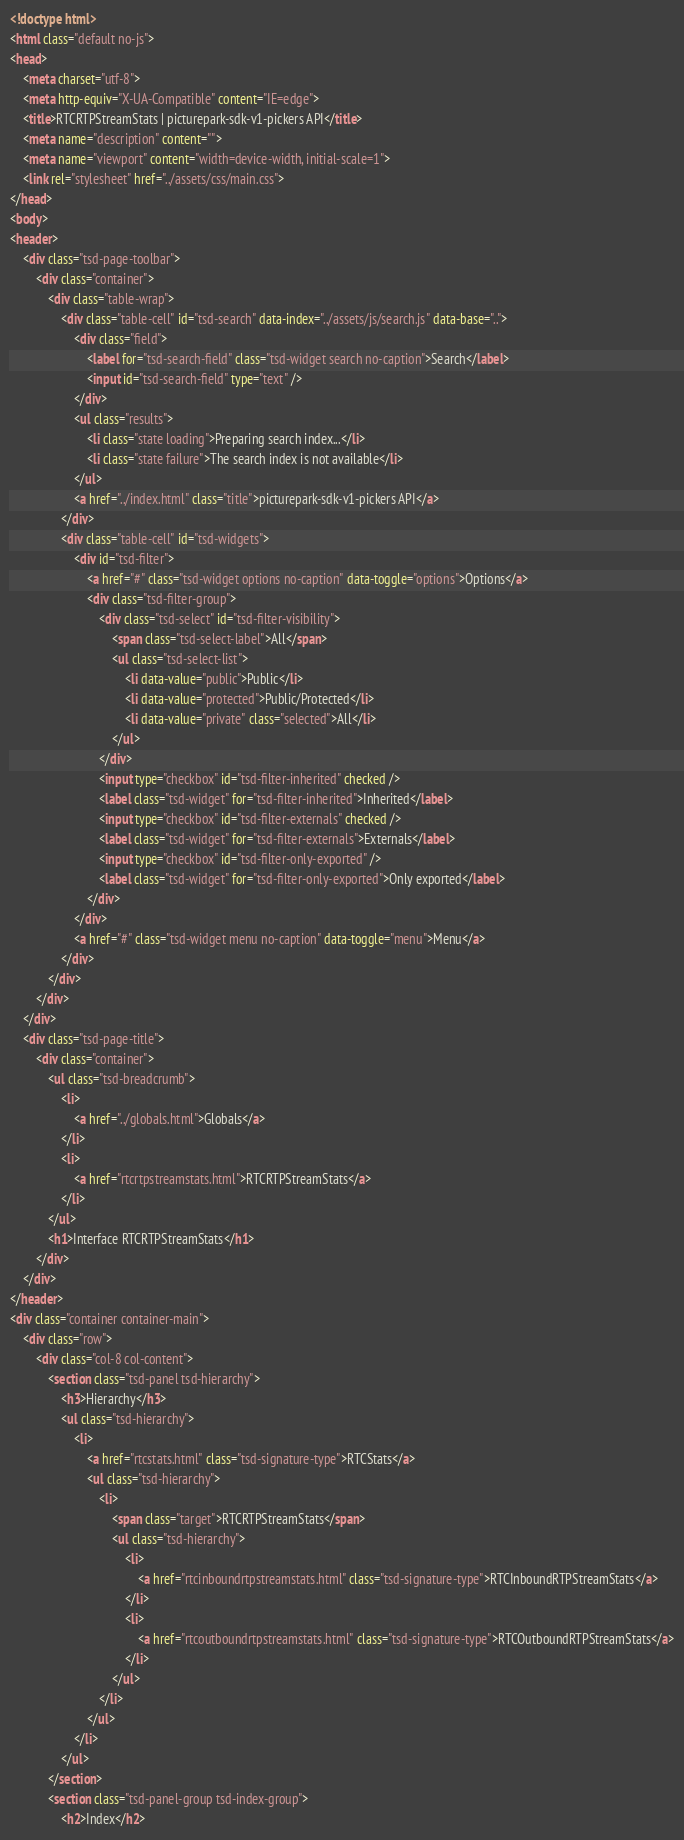<code> <loc_0><loc_0><loc_500><loc_500><_HTML_><!doctype html>
<html class="default no-js">
<head>
	<meta charset="utf-8">
	<meta http-equiv="X-UA-Compatible" content="IE=edge">
	<title>RTCRTPStreamStats | picturepark-sdk-v1-pickers API</title>
	<meta name="description" content="">
	<meta name="viewport" content="width=device-width, initial-scale=1">
	<link rel="stylesheet" href="../assets/css/main.css">
</head>
<body>
<header>
	<div class="tsd-page-toolbar">
		<div class="container">
			<div class="table-wrap">
				<div class="table-cell" id="tsd-search" data-index="../assets/js/search.js" data-base="..">
					<div class="field">
						<label for="tsd-search-field" class="tsd-widget search no-caption">Search</label>
						<input id="tsd-search-field" type="text" />
					</div>
					<ul class="results">
						<li class="state loading">Preparing search index...</li>
						<li class="state failure">The search index is not available</li>
					</ul>
					<a href="../index.html" class="title">picturepark-sdk-v1-pickers API</a>
				</div>
				<div class="table-cell" id="tsd-widgets">
					<div id="tsd-filter">
						<a href="#" class="tsd-widget options no-caption" data-toggle="options">Options</a>
						<div class="tsd-filter-group">
							<div class="tsd-select" id="tsd-filter-visibility">
								<span class="tsd-select-label">All</span>
								<ul class="tsd-select-list">
									<li data-value="public">Public</li>
									<li data-value="protected">Public/Protected</li>
									<li data-value="private" class="selected">All</li>
								</ul>
							</div>
							<input type="checkbox" id="tsd-filter-inherited" checked />
							<label class="tsd-widget" for="tsd-filter-inherited">Inherited</label>
							<input type="checkbox" id="tsd-filter-externals" checked />
							<label class="tsd-widget" for="tsd-filter-externals">Externals</label>
							<input type="checkbox" id="tsd-filter-only-exported" />
							<label class="tsd-widget" for="tsd-filter-only-exported">Only exported</label>
						</div>
					</div>
					<a href="#" class="tsd-widget menu no-caption" data-toggle="menu">Menu</a>
				</div>
			</div>
		</div>
	</div>
	<div class="tsd-page-title">
		<div class="container">
			<ul class="tsd-breadcrumb">
				<li>
					<a href="../globals.html">Globals</a>
				</li>
				<li>
					<a href="rtcrtpstreamstats.html">RTCRTPStreamStats</a>
				</li>
			</ul>
			<h1>Interface RTCRTPStreamStats</h1>
		</div>
	</div>
</header>
<div class="container container-main">
	<div class="row">
		<div class="col-8 col-content">
			<section class="tsd-panel tsd-hierarchy">
				<h3>Hierarchy</h3>
				<ul class="tsd-hierarchy">
					<li>
						<a href="rtcstats.html" class="tsd-signature-type">RTCStats</a>
						<ul class="tsd-hierarchy">
							<li>
								<span class="target">RTCRTPStreamStats</span>
								<ul class="tsd-hierarchy">
									<li>
										<a href="rtcinboundrtpstreamstats.html" class="tsd-signature-type">RTCInboundRTPStreamStats</a>
									</li>
									<li>
										<a href="rtcoutboundrtpstreamstats.html" class="tsd-signature-type">RTCOutboundRTPStreamStats</a>
									</li>
								</ul>
							</li>
						</ul>
					</li>
				</ul>
			</section>
			<section class="tsd-panel-group tsd-index-group">
				<h2>Index</h2></code> 